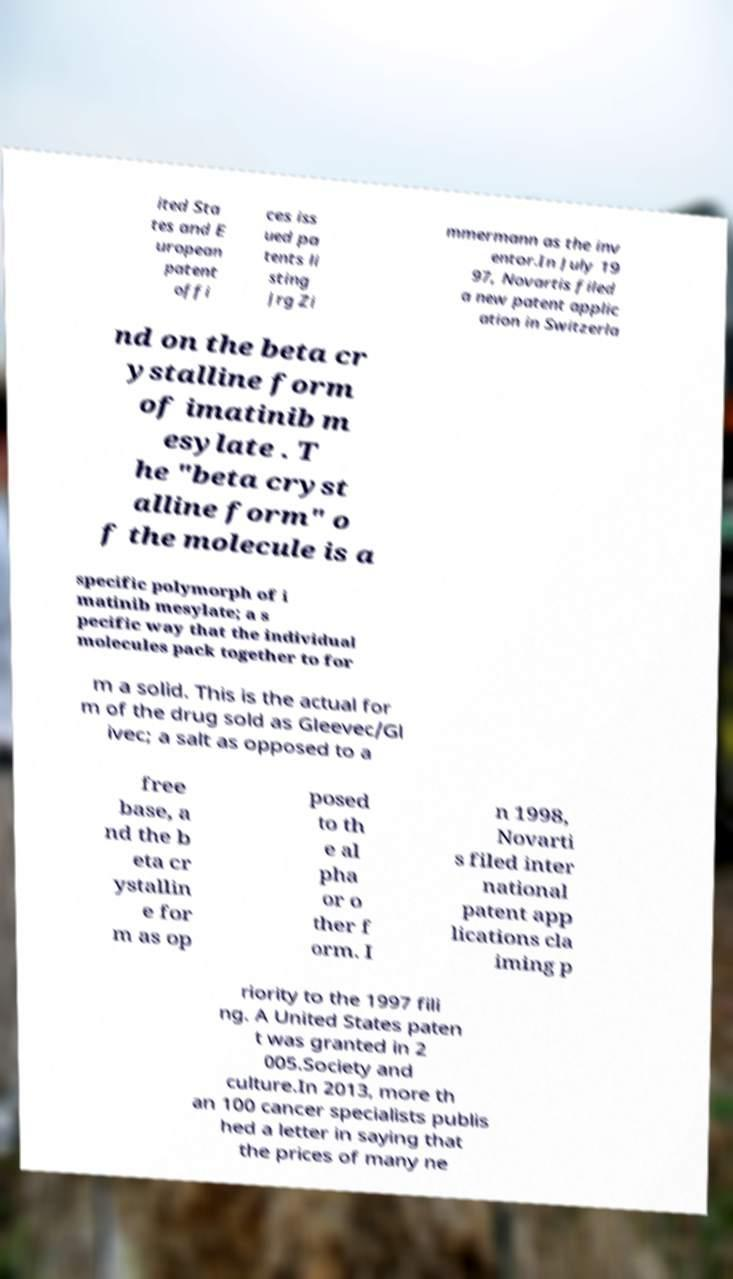I need the written content from this picture converted into text. Can you do that? ited Sta tes and E uropean patent offi ces iss ued pa tents li sting Jrg Zi mmermann as the inv entor.In July 19 97, Novartis filed a new patent applic ation in Switzerla nd on the beta cr ystalline form of imatinib m esylate . T he "beta cryst alline form" o f the molecule is a specific polymorph of i matinib mesylate; a s pecific way that the individual molecules pack together to for m a solid. This is the actual for m of the drug sold as Gleevec/Gl ivec; a salt as opposed to a free base, a nd the b eta cr ystallin e for m as op posed to th e al pha or o ther f orm. I n 1998, Novarti s filed inter national patent app lications cla iming p riority to the 1997 fili ng. A United States paten t was granted in 2 005.Society and culture.In 2013, more th an 100 cancer specialists publis hed a letter in saying that the prices of many ne 